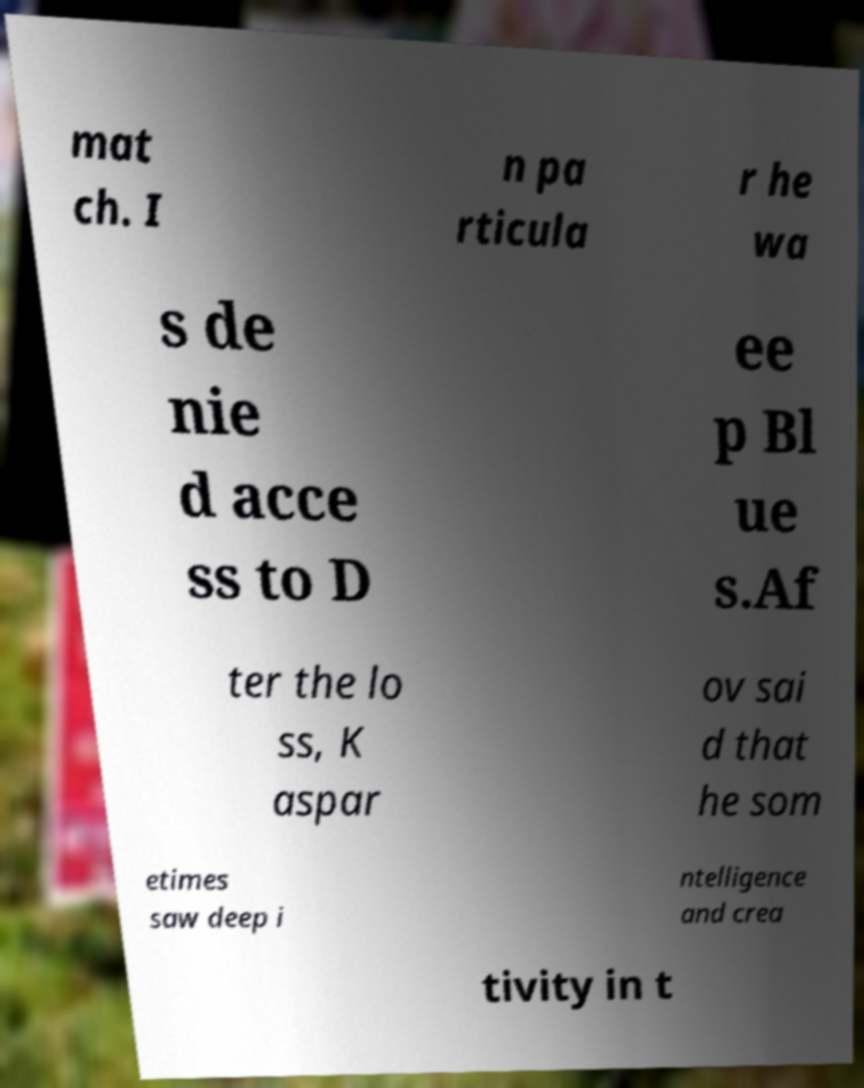Can you accurately transcribe the text from the provided image for me? mat ch. I n pa rticula r he wa s de nie d acce ss to D ee p Bl ue s.Af ter the lo ss, K aspar ov sai d that he som etimes saw deep i ntelligence and crea tivity in t 